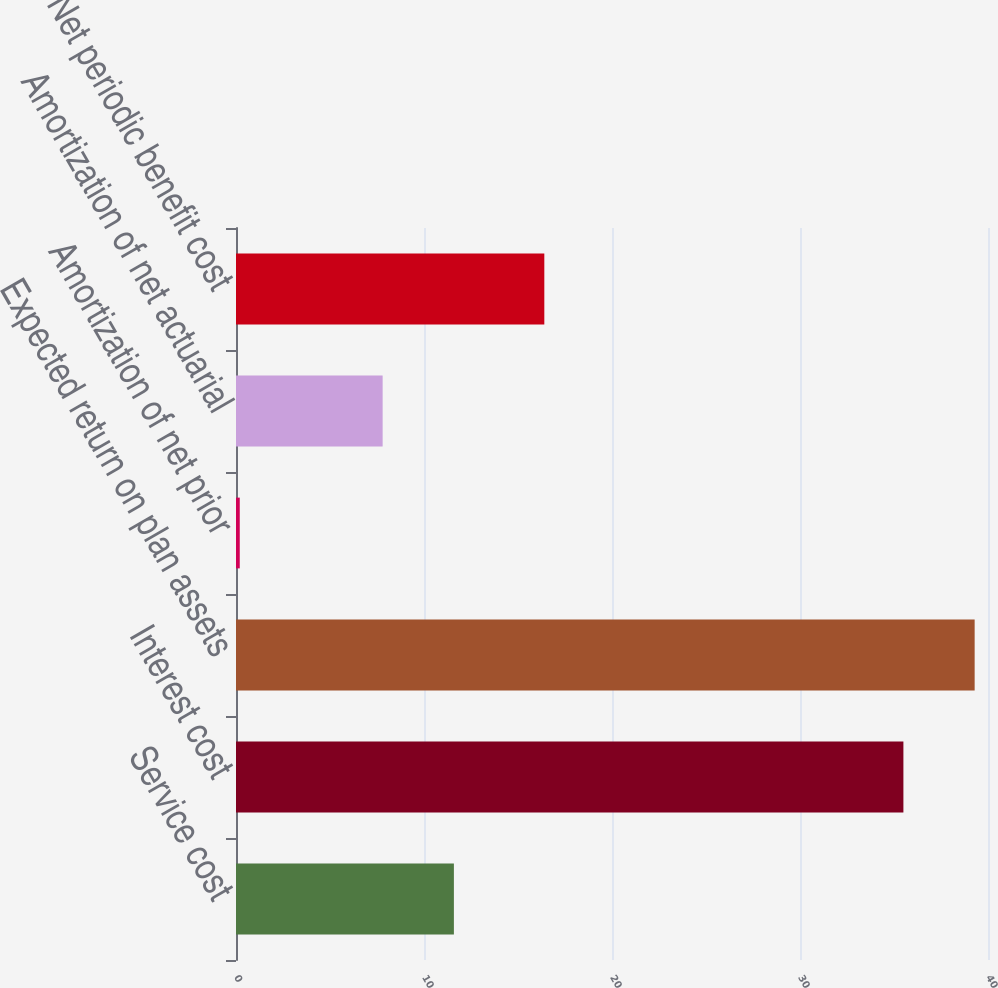Convert chart. <chart><loc_0><loc_0><loc_500><loc_500><bar_chart><fcel>Service cost<fcel>Interest cost<fcel>Expected return on plan assets<fcel>Amortization of net prior<fcel>Amortization of net actuarial<fcel>Net periodic benefit cost<nl><fcel>11.59<fcel>35.5<fcel>39.29<fcel>0.2<fcel>7.8<fcel>16.4<nl></chart> 